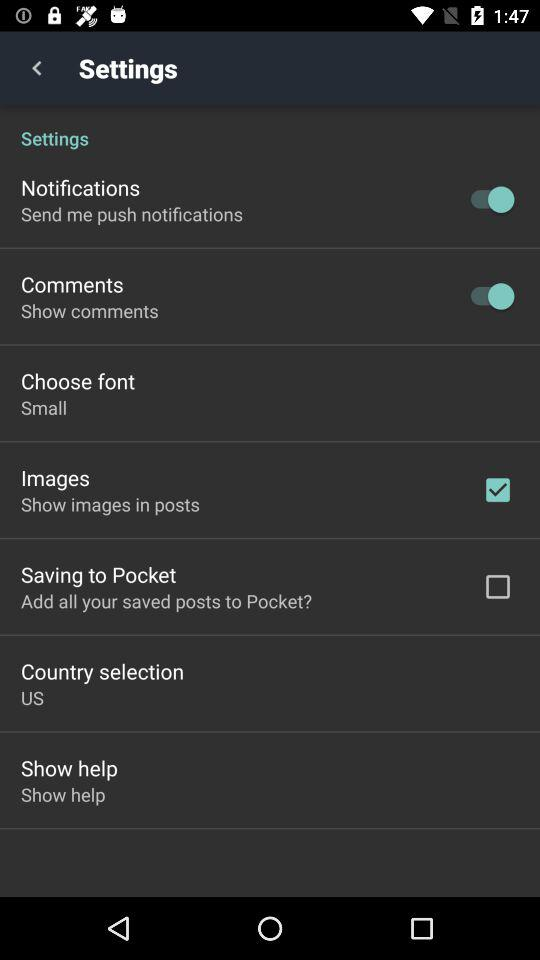Which options are checked in the application? The checked option in the application is "Images". 